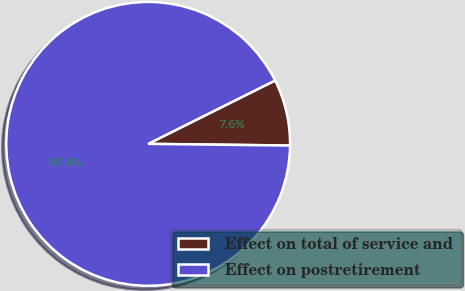Convert chart to OTSL. <chart><loc_0><loc_0><loc_500><loc_500><pie_chart><fcel>Effect on total of service and<fcel>Effect on postretirement<nl><fcel>7.56%<fcel>92.44%<nl></chart> 